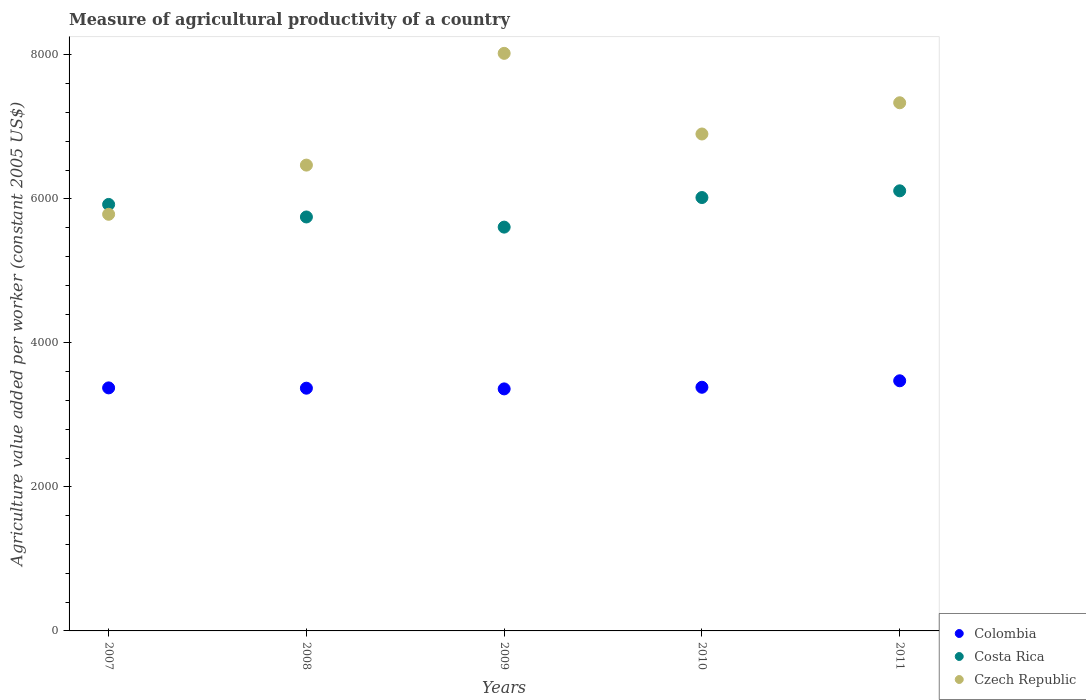What is the measure of agricultural productivity in Czech Republic in 2009?
Keep it short and to the point. 8022.62. Across all years, what is the maximum measure of agricultural productivity in Czech Republic?
Make the answer very short. 8022.62. Across all years, what is the minimum measure of agricultural productivity in Czech Republic?
Offer a terse response. 5787.25. In which year was the measure of agricultural productivity in Costa Rica maximum?
Give a very brief answer. 2011. In which year was the measure of agricultural productivity in Costa Rica minimum?
Ensure brevity in your answer.  2009. What is the total measure of agricultural productivity in Colombia in the graph?
Your response must be concise. 1.70e+04. What is the difference between the measure of agricultural productivity in Colombia in 2007 and that in 2011?
Provide a succinct answer. -98.63. What is the difference between the measure of agricultural productivity in Czech Republic in 2007 and the measure of agricultural productivity in Costa Rica in 2008?
Make the answer very short. 37.3. What is the average measure of agricultural productivity in Czech Republic per year?
Keep it short and to the point. 6903.78. In the year 2009, what is the difference between the measure of agricultural productivity in Czech Republic and measure of agricultural productivity in Colombia?
Offer a terse response. 4660.76. What is the ratio of the measure of agricultural productivity in Colombia in 2008 to that in 2011?
Offer a terse response. 0.97. Is the measure of agricultural productivity in Costa Rica in 2007 less than that in 2010?
Ensure brevity in your answer.  Yes. Is the difference between the measure of agricultural productivity in Czech Republic in 2007 and 2009 greater than the difference between the measure of agricultural productivity in Colombia in 2007 and 2009?
Your answer should be compact. No. What is the difference between the highest and the second highest measure of agricultural productivity in Czech Republic?
Give a very brief answer. 686.4. What is the difference between the highest and the lowest measure of agricultural productivity in Czech Republic?
Make the answer very short. 2235.37. Is the sum of the measure of agricultural productivity in Czech Republic in 2010 and 2011 greater than the maximum measure of agricultural productivity in Costa Rica across all years?
Your response must be concise. Yes. Does the measure of agricultural productivity in Czech Republic monotonically increase over the years?
Provide a short and direct response. No. Is the measure of agricultural productivity in Colombia strictly less than the measure of agricultural productivity in Czech Republic over the years?
Keep it short and to the point. Yes. How many dotlines are there?
Provide a succinct answer. 3. Are the values on the major ticks of Y-axis written in scientific E-notation?
Give a very brief answer. No. Where does the legend appear in the graph?
Make the answer very short. Bottom right. What is the title of the graph?
Your answer should be compact. Measure of agricultural productivity of a country. Does "Yemen, Rep." appear as one of the legend labels in the graph?
Your answer should be very brief. No. What is the label or title of the Y-axis?
Offer a very short reply. Agriculture value added per worker (constant 2005 US$). What is the Agriculture value added per worker (constant 2005 US$) of Colombia in 2007?
Keep it short and to the point. 3375.79. What is the Agriculture value added per worker (constant 2005 US$) of Costa Rica in 2007?
Keep it short and to the point. 5924.06. What is the Agriculture value added per worker (constant 2005 US$) in Czech Republic in 2007?
Your answer should be compact. 5787.25. What is the Agriculture value added per worker (constant 2005 US$) in Colombia in 2008?
Give a very brief answer. 3371.61. What is the Agriculture value added per worker (constant 2005 US$) in Costa Rica in 2008?
Offer a terse response. 5749.96. What is the Agriculture value added per worker (constant 2005 US$) of Czech Republic in 2008?
Ensure brevity in your answer.  6470.37. What is the Agriculture value added per worker (constant 2005 US$) in Colombia in 2009?
Provide a short and direct response. 3361.86. What is the Agriculture value added per worker (constant 2005 US$) of Costa Rica in 2009?
Offer a terse response. 5608.9. What is the Agriculture value added per worker (constant 2005 US$) of Czech Republic in 2009?
Ensure brevity in your answer.  8022.62. What is the Agriculture value added per worker (constant 2005 US$) in Colombia in 2010?
Provide a short and direct response. 3384.52. What is the Agriculture value added per worker (constant 2005 US$) in Costa Rica in 2010?
Ensure brevity in your answer.  6019.8. What is the Agriculture value added per worker (constant 2005 US$) of Czech Republic in 2010?
Offer a very short reply. 6902.42. What is the Agriculture value added per worker (constant 2005 US$) in Colombia in 2011?
Your response must be concise. 3474.42. What is the Agriculture value added per worker (constant 2005 US$) of Costa Rica in 2011?
Ensure brevity in your answer.  6113.25. What is the Agriculture value added per worker (constant 2005 US$) of Czech Republic in 2011?
Provide a short and direct response. 7336.22. Across all years, what is the maximum Agriculture value added per worker (constant 2005 US$) of Colombia?
Keep it short and to the point. 3474.42. Across all years, what is the maximum Agriculture value added per worker (constant 2005 US$) of Costa Rica?
Provide a succinct answer. 6113.25. Across all years, what is the maximum Agriculture value added per worker (constant 2005 US$) of Czech Republic?
Your response must be concise. 8022.62. Across all years, what is the minimum Agriculture value added per worker (constant 2005 US$) in Colombia?
Your response must be concise. 3361.86. Across all years, what is the minimum Agriculture value added per worker (constant 2005 US$) in Costa Rica?
Your response must be concise. 5608.9. Across all years, what is the minimum Agriculture value added per worker (constant 2005 US$) in Czech Republic?
Offer a very short reply. 5787.25. What is the total Agriculture value added per worker (constant 2005 US$) of Colombia in the graph?
Offer a very short reply. 1.70e+04. What is the total Agriculture value added per worker (constant 2005 US$) in Costa Rica in the graph?
Offer a very short reply. 2.94e+04. What is the total Agriculture value added per worker (constant 2005 US$) of Czech Republic in the graph?
Offer a very short reply. 3.45e+04. What is the difference between the Agriculture value added per worker (constant 2005 US$) of Colombia in 2007 and that in 2008?
Your response must be concise. 4.18. What is the difference between the Agriculture value added per worker (constant 2005 US$) of Costa Rica in 2007 and that in 2008?
Ensure brevity in your answer.  174.11. What is the difference between the Agriculture value added per worker (constant 2005 US$) in Czech Republic in 2007 and that in 2008?
Ensure brevity in your answer.  -683.12. What is the difference between the Agriculture value added per worker (constant 2005 US$) of Colombia in 2007 and that in 2009?
Ensure brevity in your answer.  13.93. What is the difference between the Agriculture value added per worker (constant 2005 US$) in Costa Rica in 2007 and that in 2009?
Keep it short and to the point. 315.17. What is the difference between the Agriculture value added per worker (constant 2005 US$) of Czech Republic in 2007 and that in 2009?
Your answer should be compact. -2235.37. What is the difference between the Agriculture value added per worker (constant 2005 US$) of Colombia in 2007 and that in 2010?
Provide a succinct answer. -8.74. What is the difference between the Agriculture value added per worker (constant 2005 US$) in Costa Rica in 2007 and that in 2010?
Provide a short and direct response. -95.73. What is the difference between the Agriculture value added per worker (constant 2005 US$) in Czech Republic in 2007 and that in 2010?
Keep it short and to the point. -1115.17. What is the difference between the Agriculture value added per worker (constant 2005 US$) of Colombia in 2007 and that in 2011?
Keep it short and to the point. -98.63. What is the difference between the Agriculture value added per worker (constant 2005 US$) of Costa Rica in 2007 and that in 2011?
Provide a succinct answer. -189.18. What is the difference between the Agriculture value added per worker (constant 2005 US$) in Czech Republic in 2007 and that in 2011?
Keep it short and to the point. -1548.97. What is the difference between the Agriculture value added per worker (constant 2005 US$) in Colombia in 2008 and that in 2009?
Your answer should be compact. 9.75. What is the difference between the Agriculture value added per worker (constant 2005 US$) in Costa Rica in 2008 and that in 2009?
Ensure brevity in your answer.  141.06. What is the difference between the Agriculture value added per worker (constant 2005 US$) in Czech Republic in 2008 and that in 2009?
Your answer should be compact. -1552.25. What is the difference between the Agriculture value added per worker (constant 2005 US$) of Colombia in 2008 and that in 2010?
Make the answer very short. -12.91. What is the difference between the Agriculture value added per worker (constant 2005 US$) in Costa Rica in 2008 and that in 2010?
Provide a short and direct response. -269.84. What is the difference between the Agriculture value added per worker (constant 2005 US$) in Czech Republic in 2008 and that in 2010?
Provide a succinct answer. -432.05. What is the difference between the Agriculture value added per worker (constant 2005 US$) in Colombia in 2008 and that in 2011?
Make the answer very short. -102.81. What is the difference between the Agriculture value added per worker (constant 2005 US$) in Costa Rica in 2008 and that in 2011?
Provide a short and direct response. -363.29. What is the difference between the Agriculture value added per worker (constant 2005 US$) in Czech Republic in 2008 and that in 2011?
Make the answer very short. -865.85. What is the difference between the Agriculture value added per worker (constant 2005 US$) in Colombia in 2009 and that in 2010?
Offer a very short reply. -22.67. What is the difference between the Agriculture value added per worker (constant 2005 US$) in Costa Rica in 2009 and that in 2010?
Ensure brevity in your answer.  -410.9. What is the difference between the Agriculture value added per worker (constant 2005 US$) of Czech Republic in 2009 and that in 2010?
Ensure brevity in your answer.  1120.2. What is the difference between the Agriculture value added per worker (constant 2005 US$) in Colombia in 2009 and that in 2011?
Offer a very short reply. -112.56. What is the difference between the Agriculture value added per worker (constant 2005 US$) of Costa Rica in 2009 and that in 2011?
Offer a very short reply. -504.35. What is the difference between the Agriculture value added per worker (constant 2005 US$) of Czech Republic in 2009 and that in 2011?
Provide a short and direct response. 686.4. What is the difference between the Agriculture value added per worker (constant 2005 US$) in Colombia in 2010 and that in 2011?
Provide a succinct answer. -89.9. What is the difference between the Agriculture value added per worker (constant 2005 US$) in Costa Rica in 2010 and that in 2011?
Offer a terse response. -93.45. What is the difference between the Agriculture value added per worker (constant 2005 US$) in Czech Republic in 2010 and that in 2011?
Give a very brief answer. -433.8. What is the difference between the Agriculture value added per worker (constant 2005 US$) of Colombia in 2007 and the Agriculture value added per worker (constant 2005 US$) of Costa Rica in 2008?
Ensure brevity in your answer.  -2374.17. What is the difference between the Agriculture value added per worker (constant 2005 US$) in Colombia in 2007 and the Agriculture value added per worker (constant 2005 US$) in Czech Republic in 2008?
Keep it short and to the point. -3094.58. What is the difference between the Agriculture value added per worker (constant 2005 US$) of Costa Rica in 2007 and the Agriculture value added per worker (constant 2005 US$) of Czech Republic in 2008?
Provide a short and direct response. -546.3. What is the difference between the Agriculture value added per worker (constant 2005 US$) in Colombia in 2007 and the Agriculture value added per worker (constant 2005 US$) in Costa Rica in 2009?
Provide a short and direct response. -2233.11. What is the difference between the Agriculture value added per worker (constant 2005 US$) of Colombia in 2007 and the Agriculture value added per worker (constant 2005 US$) of Czech Republic in 2009?
Make the answer very short. -4646.83. What is the difference between the Agriculture value added per worker (constant 2005 US$) in Costa Rica in 2007 and the Agriculture value added per worker (constant 2005 US$) in Czech Republic in 2009?
Make the answer very short. -2098.55. What is the difference between the Agriculture value added per worker (constant 2005 US$) in Colombia in 2007 and the Agriculture value added per worker (constant 2005 US$) in Costa Rica in 2010?
Provide a short and direct response. -2644.01. What is the difference between the Agriculture value added per worker (constant 2005 US$) of Colombia in 2007 and the Agriculture value added per worker (constant 2005 US$) of Czech Republic in 2010?
Ensure brevity in your answer.  -3526.63. What is the difference between the Agriculture value added per worker (constant 2005 US$) of Costa Rica in 2007 and the Agriculture value added per worker (constant 2005 US$) of Czech Republic in 2010?
Your answer should be compact. -978.35. What is the difference between the Agriculture value added per worker (constant 2005 US$) of Colombia in 2007 and the Agriculture value added per worker (constant 2005 US$) of Costa Rica in 2011?
Offer a very short reply. -2737.46. What is the difference between the Agriculture value added per worker (constant 2005 US$) of Colombia in 2007 and the Agriculture value added per worker (constant 2005 US$) of Czech Republic in 2011?
Offer a terse response. -3960.43. What is the difference between the Agriculture value added per worker (constant 2005 US$) in Costa Rica in 2007 and the Agriculture value added per worker (constant 2005 US$) in Czech Republic in 2011?
Offer a terse response. -1412.16. What is the difference between the Agriculture value added per worker (constant 2005 US$) of Colombia in 2008 and the Agriculture value added per worker (constant 2005 US$) of Costa Rica in 2009?
Your answer should be compact. -2237.28. What is the difference between the Agriculture value added per worker (constant 2005 US$) in Colombia in 2008 and the Agriculture value added per worker (constant 2005 US$) in Czech Republic in 2009?
Your answer should be compact. -4651.01. What is the difference between the Agriculture value added per worker (constant 2005 US$) in Costa Rica in 2008 and the Agriculture value added per worker (constant 2005 US$) in Czech Republic in 2009?
Provide a succinct answer. -2272.66. What is the difference between the Agriculture value added per worker (constant 2005 US$) in Colombia in 2008 and the Agriculture value added per worker (constant 2005 US$) in Costa Rica in 2010?
Your answer should be very brief. -2648.18. What is the difference between the Agriculture value added per worker (constant 2005 US$) of Colombia in 2008 and the Agriculture value added per worker (constant 2005 US$) of Czech Republic in 2010?
Make the answer very short. -3530.81. What is the difference between the Agriculture value added per worker (constant 2005 US$) in Costa Rica in 2008 and the Agriculture value added per worker (constant 2005 US$) in Czech Republic in 2010?
Your response must be concise. -1152.46. What is the difference between the Agriculture value added per worker (constant 2005 US$) of Colombia in 2008 and the Agriculture value added per worker (constant 2005 US$) of Costa Rica in 2011?
Your answer should be compact. -2741.64. What is the difference between the Agriculture value added per worker (constant 2005 US$) in Colombia in 2008 and the Agriculture value added per worker (constant 2005 US$) in Czech Republic in 2011?
Your answer should be compact. -3964.61. What is the difference between the Agriculture value added per worker (constant 2005 US$) in Costa Rica in 2008 and the Agriculture value added per worker (constant 2005 US$) in Czech Republic in 2011?
Provide a short and direct response. -1586.26. What is the difference between the Agriculture value added per worker (constant 2005 US$) in Colombia in 2009 and the Agriculture value added per worker (constant 2005 US$) in Costa Rica in 2010?
Offer a very short reply. -2657.94. What is the difference between the Agriculture value added per worker (constant 2005 US$) in Colombia in 2009 and the Agriculture value added per worker (constant 2005 US$) in Czech Republic in 2010?
Your answer should be compact. -3540.56. What is the difference between the Agriculture value added per worker (constant 2005 US$) in Costa Rica in 2009 and the Agriculture value added per worker (constant 2005 US$) in Czech Republic in 2010?
Offer a very short reply. -1293.52. What is the difference between the Agriculture value added per worker (constant 2005 US$) in Colombia in 2009 and the Agriculture value added per worker (constant 2005 US$) in Costa Rica in 2011?
Your response must be concise. -2751.39. What is the difference between the Agriculture value added per worker (constant 2005 US$) in Colombia in 2009 and the Agriculture value added per worker (constant 2005 US$) in Czech Republic in 2011?
Offer a very short reply. -3974.36. What is the difference between the Agriculture value added per worker (constant 2005 US$) in Costa Rica in 2009 and the Agriculture value added per worker (constant 2005 US$) in Czech Republic in 2011?
Make the answer very short. -1727.33. What is the difference between the Agriculture value added per worker (constant 2005 US$) of Colombia in 2010 and the Agriculture value added per worker (constant 2005 US$) of Costa Rica in 2011?
Ensure brevity in your answer.  -2728.73. What is the difference between the Agriculture value added per worker (constant 2005 US$) of Colombia in 2010 and the Agriculture value added per worker (constant 2005 US$) of Czech Republic in 2011?
Give a very brief answer. -3951.7. What is the difference between the Agriculture value added per worker (constant 2005 US$) of Costa Rica in 2010 and the Agriculture value added per worker (constant 2005 US$) of Czech Republic in 2011?
Give a very brief answer. -1316.43. What is the average Agriculture value added per worker (constant 2005 US$) of Colombia per year?
Give a very brief answer. 3393.64. What is the average Agriculture value added per worker (constant 2005 US$) in Costa Rica per year?
Provide a short and direct response. 5883.19. What is the average Agriculture value added per worker (constant 2005 US$) in Czech Republic per year?
Provide a succinct answer. 6903.78. In the year 2007, what is the difference between the Agriculture value added per worker (constant 2005 US$) of Colombia and Agriculture value added per worker (constant 2005 US$) of Costa Rica?
Provide a short and direct response. -2548.28. In the year 2007, what is the difference between the Agriculture value added per worker (constant 2005 US$) in Colombia and Agriculture value added per worker (constant 2005 US$) in Czech Republic?
Provide a succinct answer. -2411.47. In the year 2007, what is the difference between the Agriculture value added per worker (constant 2005 US$) in Costa Rica and Agriculture value added per worker (constant 2005 US$) in Czech Republic?
Ensure brevity in your answer.  136.81. In the year 2008, what is the difference between the Agriculture value added per worker (constant 2005 US$) in Colombia and Agriculture value added per worker (constant 2005 US$) in Costa Rica?
Provide a succinct answer. -2378.34. In the year 2008, what is the difference between the Agriculture value added per worker (constant 2005 US$) of Colombia and Agriculture value added per worker (constant 2005 US$) of Czech Republic?
Your response must be concise. -3098.76. In the year 2008, what is the difference between the Agriculture value added per worker (constant 2005 US$) in Costa Rica and Agriculture value added per worker (constant 2005 US$) in Czech Republic?
Make the answer very short. -720.41. In the year 2009, what is the difference between the Agriculture value added per worker (constant 2005 US$) of Colombia and Agriculture value added per worker (constant 2005 US$) of Costa Rica?
Offer a terse response. -2247.04. In the year 2009, what is the difference between the Agriculture value added per worker (constant 2005 US$) in Colombia and Agriculture value added per worker (constant 2005 US$) in Czech Republic?
Ensure brevity in your answer.  -4660.76. In the year 2009, what is the difference between the Agriculture value added per worker (constant 2005 US$) in Costa Rica and Agriculture value added per worker (constant 2005 US$) in Czech Republic?
Your answer should be very brief. -2413.72. In the year 2010, what is the difference between the Agriculture value added per worker (constant 2005 US$) of Colombia and Agriculture value added per worker (constant 2005 US$) of Costa Rica?
Ensure brevity in your answer.  -2635.27. In the year 2010, what is the difference between the Agriculture value added per worker (constant 2005 US$) of Colombia and Agriculture value added per worker (constant 2005 US$) of Czech Republic?
Offer a terse response. -3517.9. In the year 2010, what is the difference between the Agriculture value added per worker (constant 2005 US$) of Costa Rica and Agriculture value added per worker (constant 2005 US$) of Czech Republic?
Offer a terse response. -882.62. In the year 2011, what is the difference between the Agriculture value added per worker (constant 2005 US$) in Colombia and Agriculture value added per worker (constant 2005 US$) in Costa Rica?
Provide a succinct answer. -2638.83. In the year 2011, what is the difference between the Agriculture value added per worker (constant 2005 US$) in Colombia and Agriculture value added per worker (constant 2005 US$) in Czech Republic?
Provide a succinct answer. -3861.8. In the year 2011, what is the difference between the Agriculture value added per worker (constant 2005 US$) in Costa Rica and Agriculture value added per worker (constant 2005 US$) in Czech Republic?
Offer a terse response. -1222.97. What is the ratio of the Agriculture value added per worker (constant 2005 US$) in Colombia in 2007 to that in 2008?
Keep it short and to the point. 1. What is the ratio of the Agriculture value added per worker (constant 2005 US$) of Costa Rica in 2007 to that in 2008?
Your response must be concise. 1.03. What is the ratio of the Agriculture value added per worker (constant 2005 US$) of Czech Republic in 2007 to that in 2008?
Your answer should be very brief. 0.89. What is the ratio of the Agriculture value added per worker (constant 2005 US$) of Costa Rica in 2007 to that in 2009?
Offer a very short reply. 1.06. What is the ratio of the Agriculture value added per worker (constant 2005 US$) of Czech Republic in 2007 to that in 2009?
Provide a short and direct response. 0.72. What is the ratio of the Agriculture value added per worker (constant 2005 US$) of Costa Rica in 2007 to that in 2010?
Keep it short and to the point. 0.98. What is the ratio of the Agriculture value added per worker (constant 2005 US$) in Czech Republic in 2007 to that in 2010?
Offer a terse response. 0.84. What is the ratio of the Agriculture value added per worker (constant 2005 US$) in Colombia in 2007 to that in 2011?
Your answer should be compact. 0.97. What is the ratio of the Agriculture value added per worker (constant 2005 US$) of Costa Rica in 2007 to that in 2011?
Your response must be concise. 0.97. What is the ratio of the Agriculture value added per worker (constant 2005 US$) of Czech Republic in 2007 to that in 2011?
Ensure brevity in your answer.  0.79. What is the ratio of the Agriculture value added per worker (constant 2005 US$) in Colombia in 2008 to that in 2009?
Your answer should be compact. 1. What is the ratio of the Agriculture value added per worker (constant 2005 US$) in Costa Rica in 2008 to that in 2009?
Keep it short and to the point. 1.03. What is the ratio of the Agriculture value added per worker (constant 2005 US$) of Czech Republic in 2008 to that in 2009?
Keep it short and to the point. 0.81. What is the ratio of the Agriculture value added per worker (constant 2005 US$) of Costa Rica in 2008 to that in 2010?
Give a very brief answer. 0.96. What is the ratio of the Agriculture value added per worker (constant 2005 US$) of Czech Republic in 2008 to that in 2010?
Offer a very short reply. 0.94. What is the ratio of the Agriculture value added per worker (constant 2005 US$) in Colombia in 2008 to that in 2011?
Offer a terse response. 0.97. What is the ratio of the Agriculture value added per worker (constant 2005 US$) in Costa Rica in 2008 to that in 2011?
Offer a terse response. 0.94. What is the ratio of the Agriculture value added per worker (constant 2005 US$) in Czech Republic in 2008 to that in 2011?
Provide a succinct answer. 0.88. What is the ratio of the Agriculture value added per worker (constant 2005 US$) of Colombia in 2009 to that in 2010?
Offer a terse response. 0.99. What is the ratio of the Agriculture value added per worker (constant 2005 US$) of Costa Rica in 2009 to that in 2010?
Your answer should be compact. 0.93. What is the ratio of the Agriculture value added per worker (constant 2005 US$) of Czech Republic in 2009 to that in 2010?
Your response must be concise. 1.16. What is the ratio of the Agriculture value added per worker (constant 2005 US$) of Colombia in 2009 to that in 2011?
Provide a succinct answer. 0.97. What is the ratio of the Agriculture value added per worker (constant 2005 US$) in Costa Rica in 2009 to that in 2011?
Offer a terse response. 0.92. What is the ratio of the Agriculture value added per worker (constant 2005 US$) of Czech Republic in 2009 to that in 2011?
Offer a terse response. 1.09. What is the ratio of the Agriculture value added per worker (constant 2005 US$) of Colombia in 2010 to that in 2011?
Provide a succinct answer. 0.97. What is the ratio of the Agriculture value added per worker (constant 2005 US$) of Costa Rica in 2010 to that in 2011?
Offer a terse response. 0.98. What is the ratio of the Agriculture value added per worker (constant 2005 US$) of Czech Republic in 2010 to that in 2011?
Make the answer very short. 0.94. What is the difference between the highest and the second highest Agriculture value added per worker (constant 2005 US$) of Colombia?
Give a very brief answer. 89.9. What is the difference between the highest and the second highest Agriculture value added per worker (constant 2005 US$) in Costa Rica?
Ensure brevity in your answer.  93.45. What is the difference between the highest and the second highest Agriculture value added per worker (constant 2005 US$) in Czech Republic?
Ensure brevity in your answer.  686.4. What is the difference between the highest and the lowest Agriculture value added per worker (constant 2005 US$) in Colombia?
Your response must be concise. 112.56. What is the difference between the highest and the lowest Agriculture value added per worker (constant 2005 US$) of Costa Rica?
Your answer should be compact. 504.35. What is the difference between the highest and the lowest Agriculture value added per worker (constant 2005 US$) of Czech Republic?
Keep it short and to the point. 2235.37. 